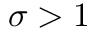<formula> <loc_0><loc_0><loc_500><loc_500>\sigma > 1</formula> 